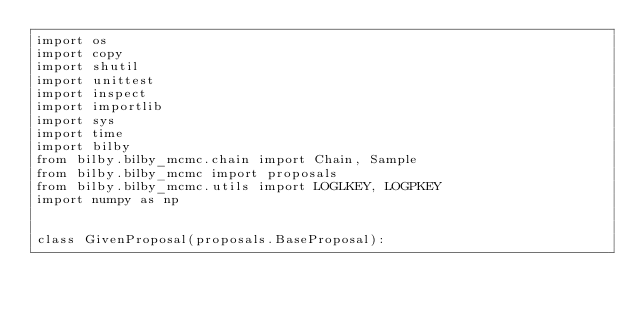<code> <loc_0><loc_0><loc_500><loc_500><_Python_>import os
import copy
import shutil
import unittest
import inspect
import importlib
import sys
import time
import bilby
from bilby.bilby_mcmc.chain import Chain, Sample
from bilby.bilby_mcmc import proposals
from bilby.bilby_mcmc.utils import LOGLKEY, LOGPKEY
import numpy as np


class GivenProposal(proposals.BaseProposal):</code> 